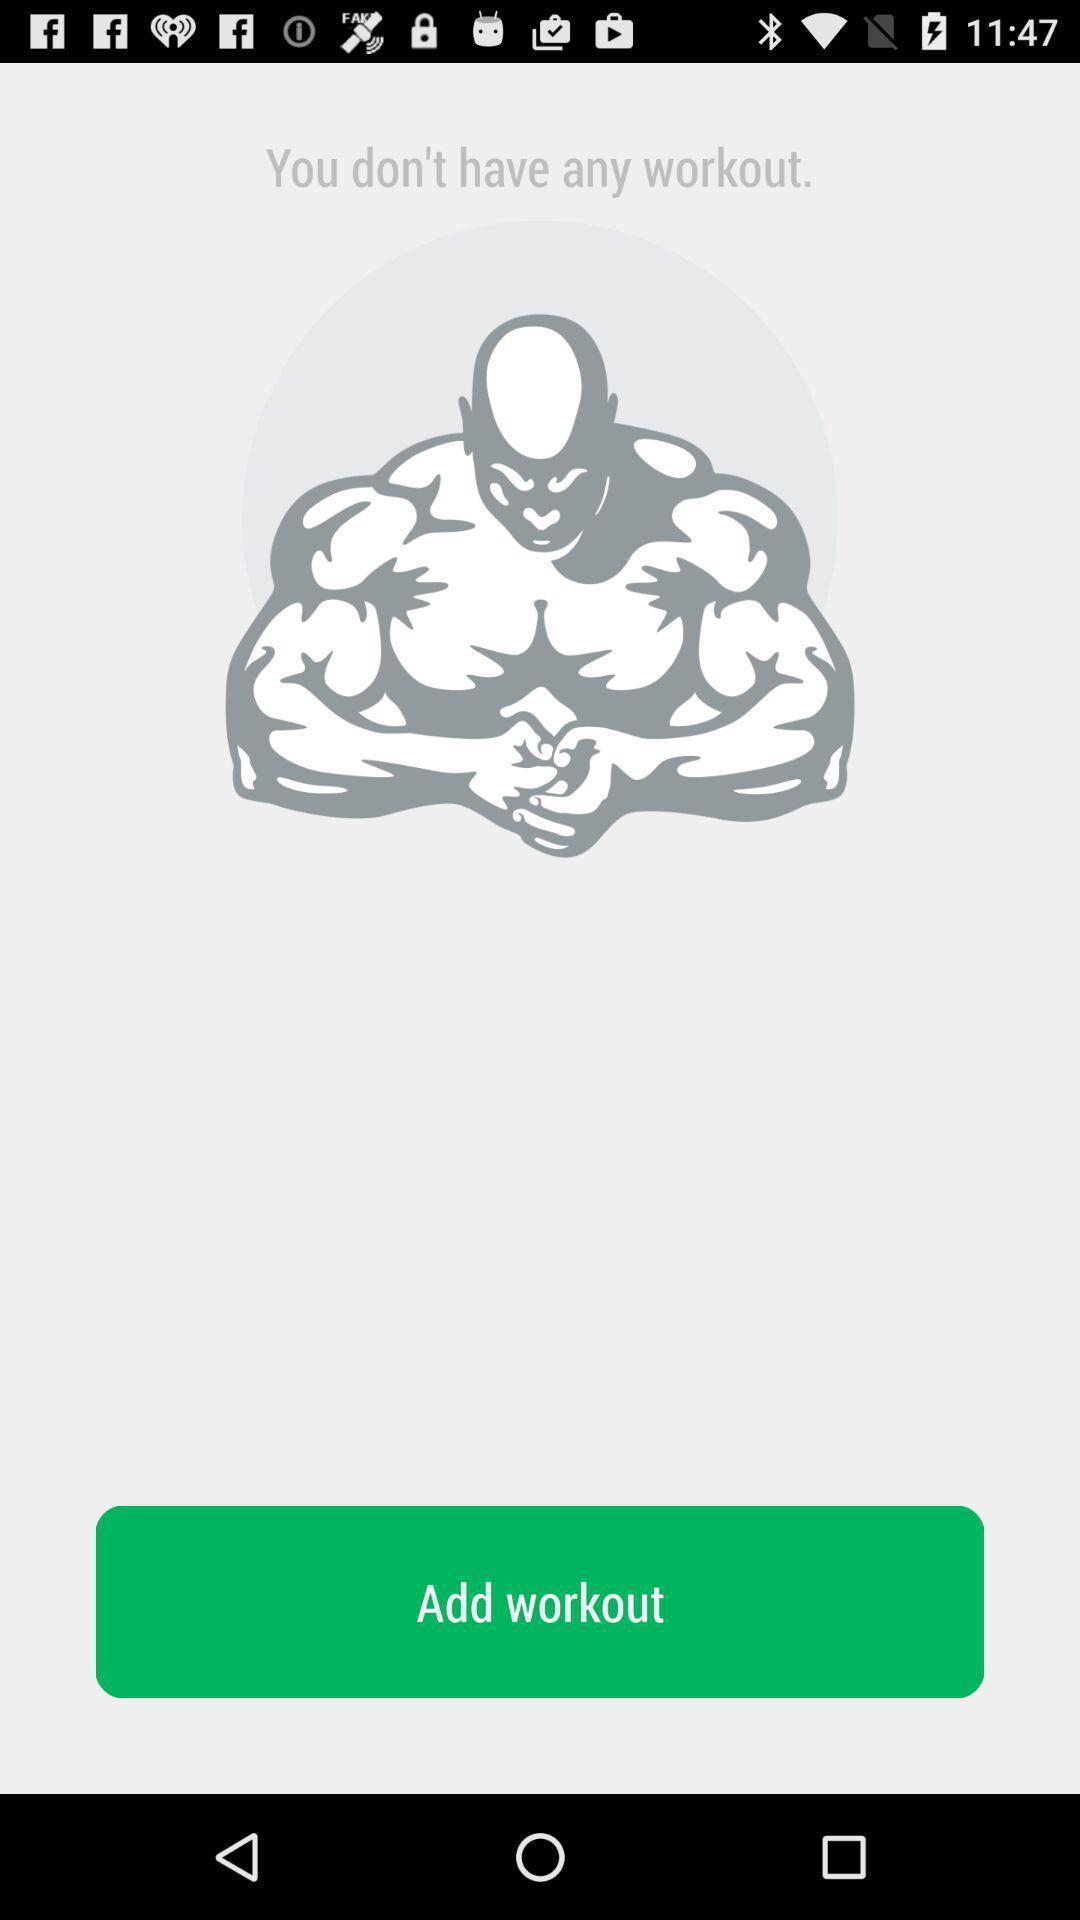What details can you identify in this image? Workout page. 